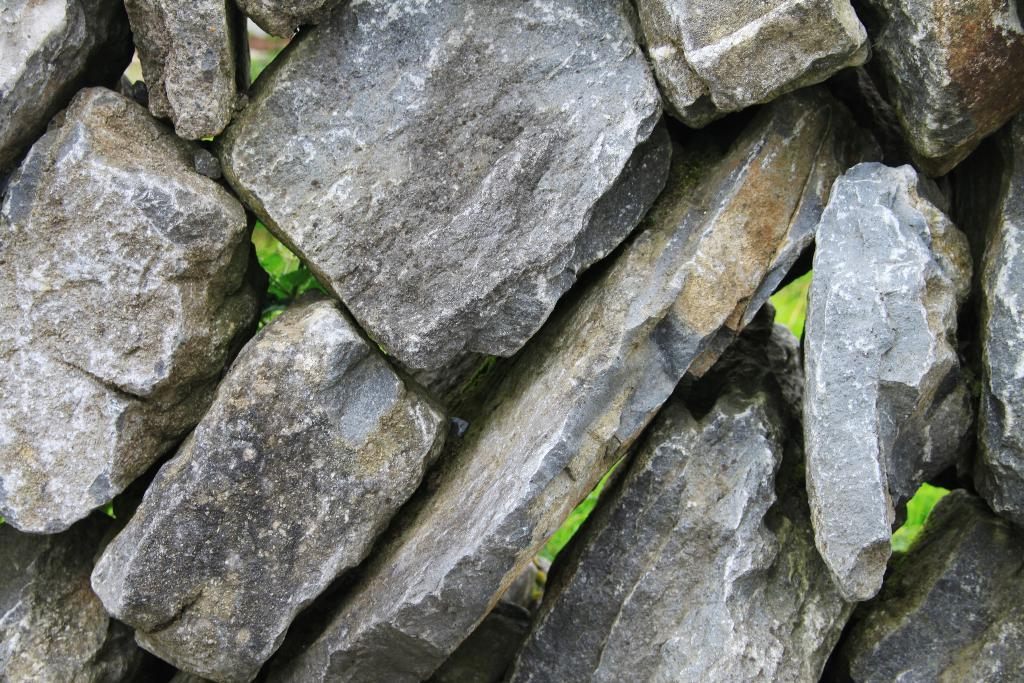What type of structure is in the image? There is a stone wall in the image. What type of vegetation can be seen in the image? There is grass visible in the image. What else can be found on the ground in the image? Leaves are present on the ground in the image. What color is the sock in the image? There is no sock present in the image. How many circles can be found in the image? There are no circles present in the image. 